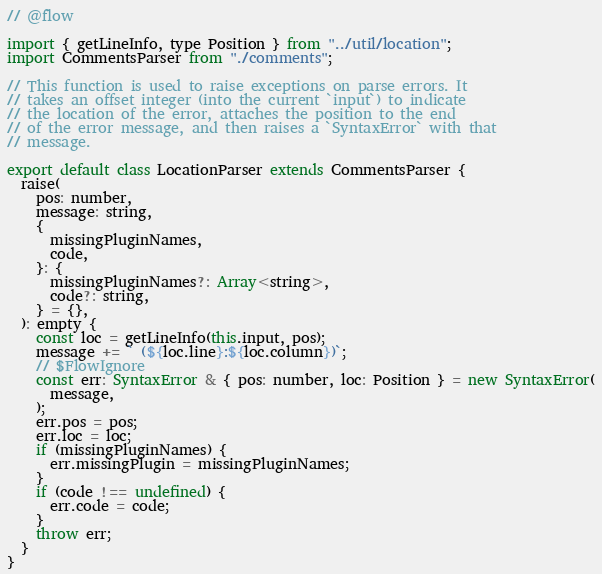Convert code to text. <code><loc_0><loc_0><loc_500><loc_500><_JavaScript_>// @flow

import { getLineInfo, type Position } from "../util/location";
import CommentsParser from "./comments";

// This function is used to raise exceptions on parse errors. It
// takes an offset integer (into the current `input`) to indicate
// the location of the error, attaches the position to the end
// of the error message, and then raises a `SyntaxError` with that
// message.

export default class LocationParser extends CommentsParser {
  raise(
    pos: number,
    message: string,
    {
      missingPluginNames,
      code,
    }: {
      missingPluginNames?: Array<string>,
      code?: string,
    } = {},
  ): empty {
    const loc = getLineInfo(this.input, pos);
    message += ` (${loc.line}:${loc.column})`;
    // $FlowIgnore
    const err: SyntaxError & { pos: number, loc: Position } = new SyntaxError(
      message,
    );
    err.pos = pos;
    err.loc = loc;
    if (missingPluginNames) {
      err.missingPlugin = missingPluginNames;
    }
    if (code !== undefined) {
      err.code = code;
    }
    throw err;
  }
}
</code> 